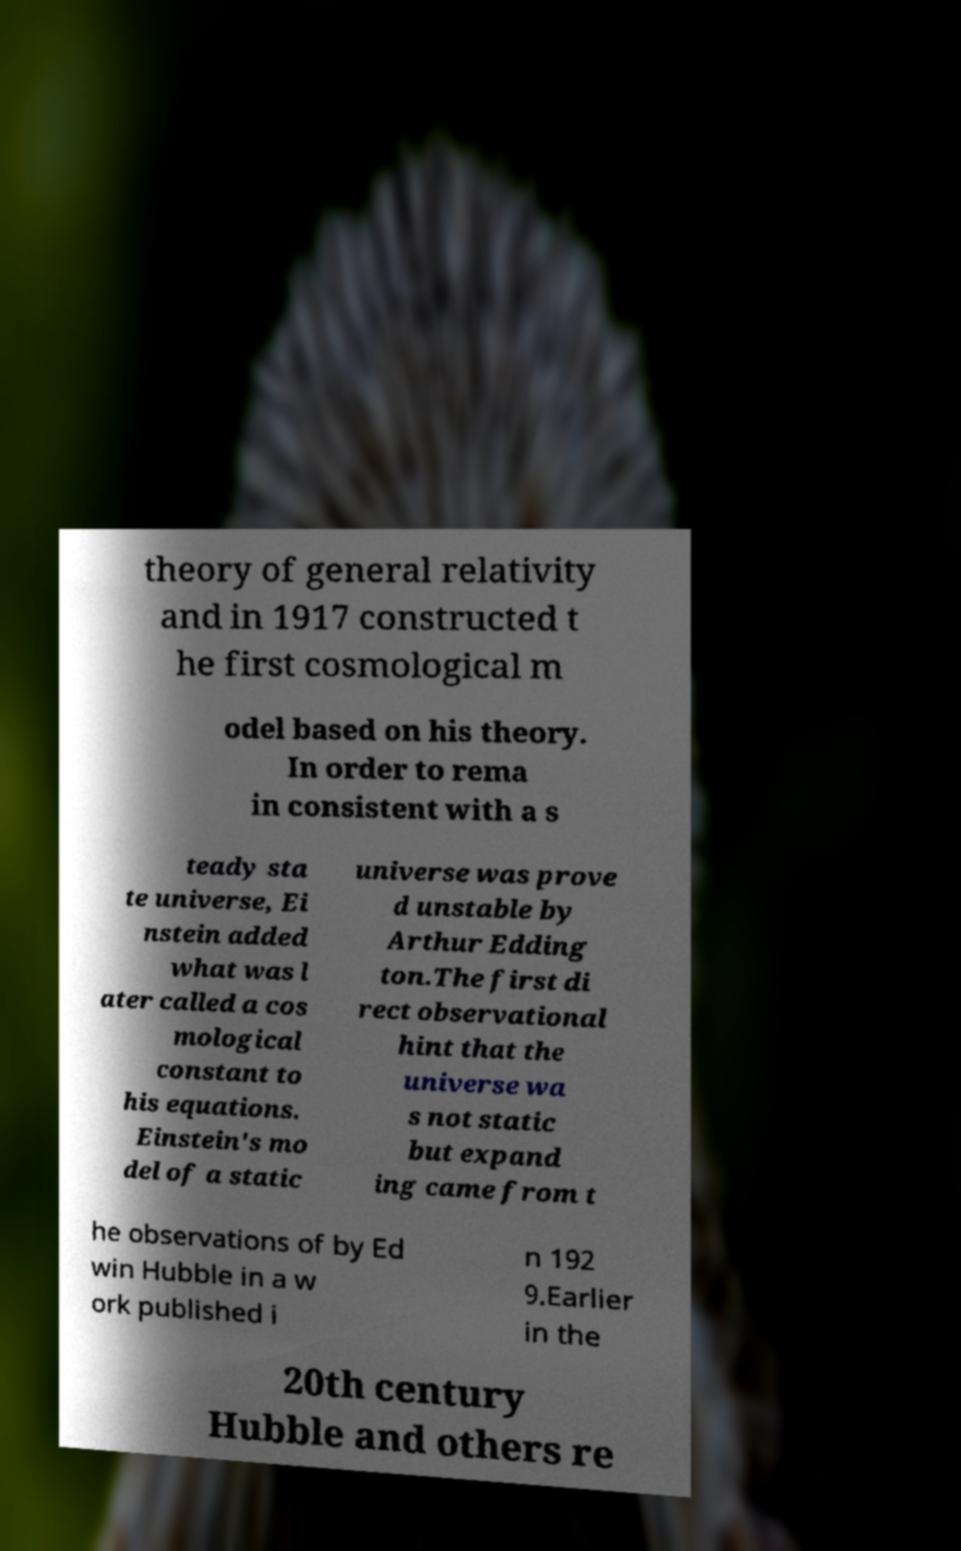There's text embedded in this image that I need extracted. Can you transcribe it verbatim? theory of general relativity and in 1917 constructed t he first cosmological m odel based on his theory. In order to rema in consistent with a s teady sta te universe, Ei nstein added what was l ater called a cos mological constant to his equations. Einstein's mo del of a static universe was prove d unstable by Arthur Edding ton.The first di rect observational hint that the universe wa s not static but expand ing came from t he observations of by Ed win Hubble in a w ork published i n 192 9.Earlier in the 20th century Hubble and others re 